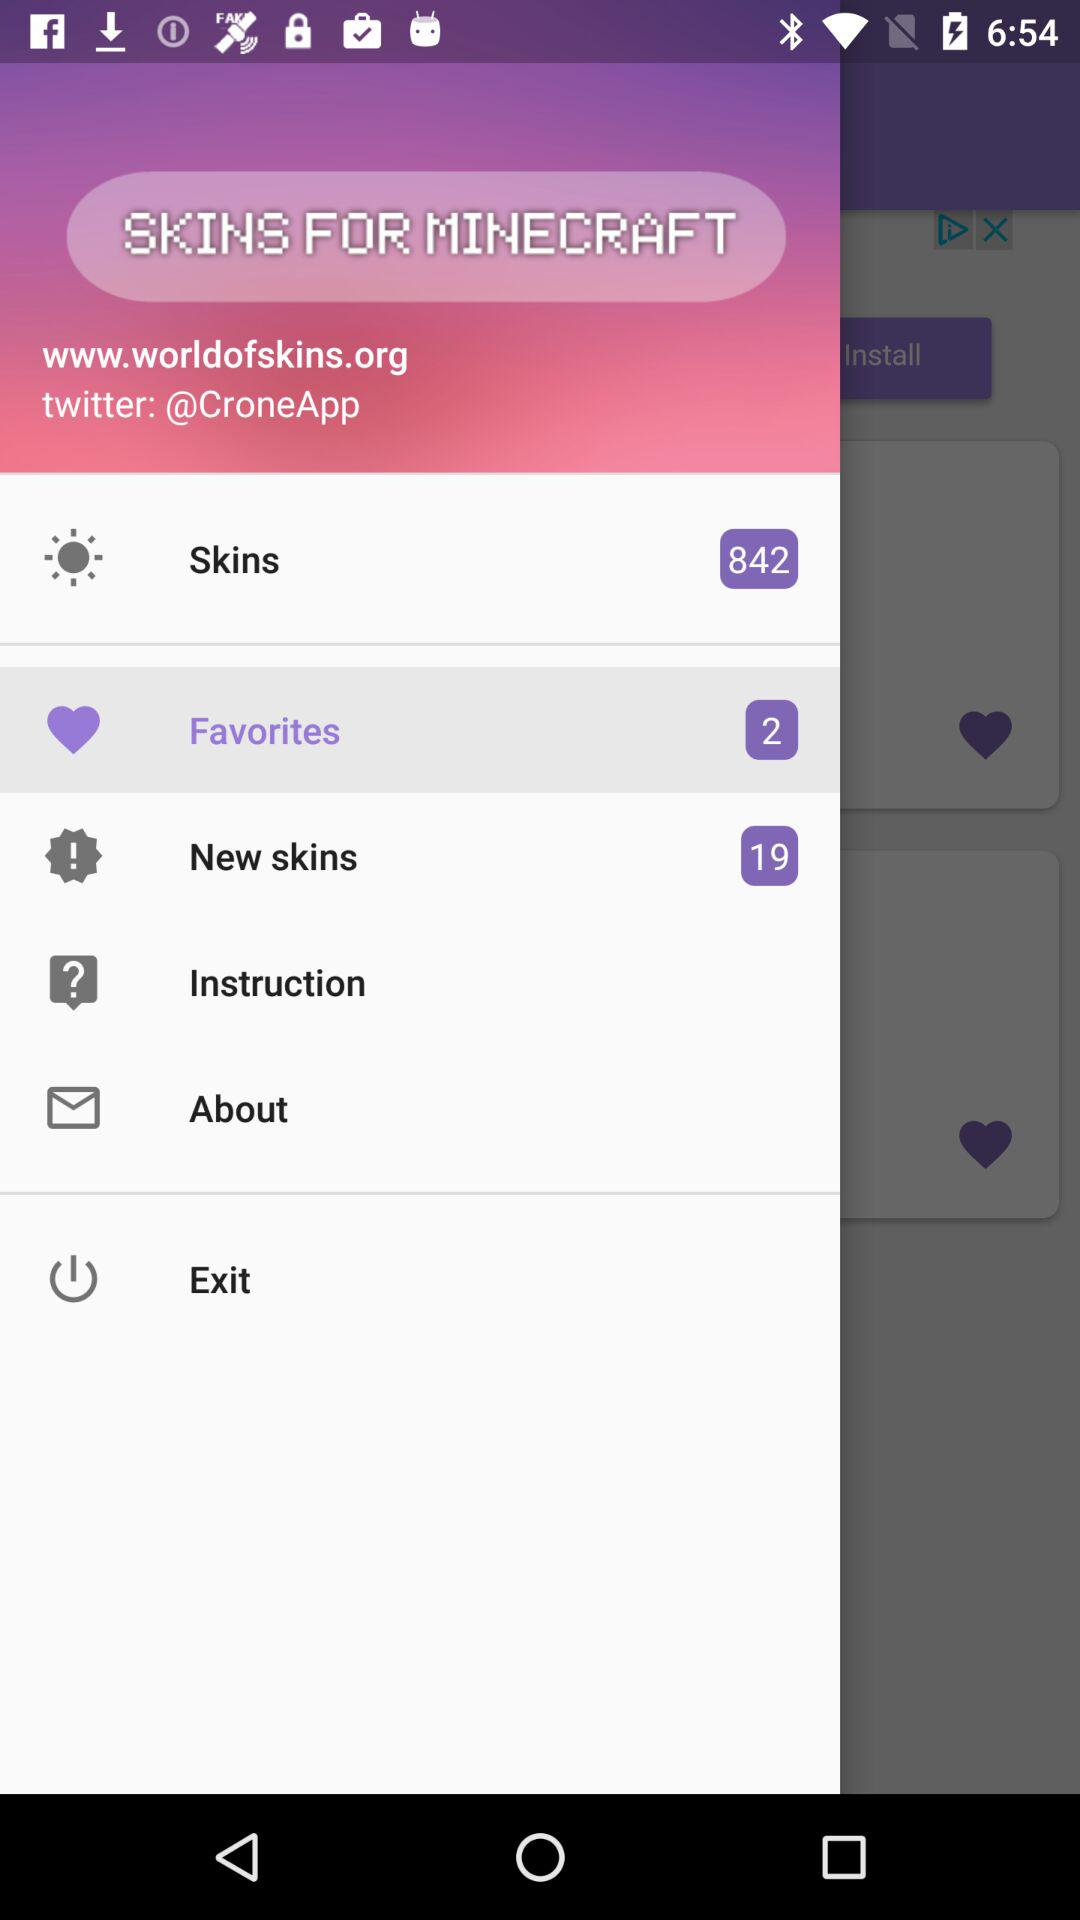How many "New skins" notifications are there? There are 19 notifications. 